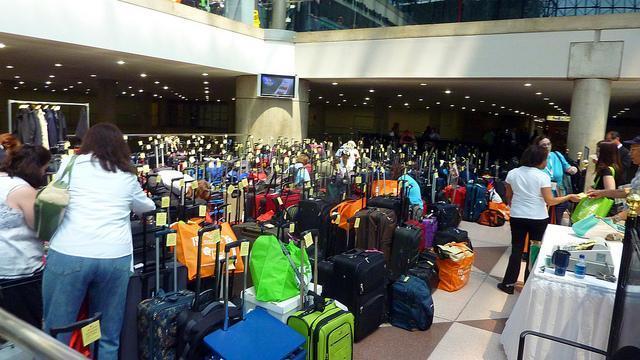How many handbags are in the picture?
Give a very brief answer. 3. How many suitcases are in the photo?
Give a very brief answer. 7. How many people are visible?
Give a very brief answer. 3. How many kites are being flown?
Give a very brief answer. 0. 